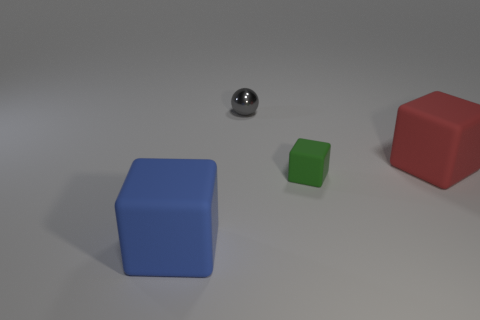What number of other things are there of the same size as the red block?
Provide a short and direct response. 1. How many large rubber cubes are on the left side of the blue cube?
Your response must be concise. 0. The blue rubber thing has what size?
Your response must be concise. Large. Does the cube that is left of the green rubber object have the same material as the tiny thing behind the red rubber block?
Your answer should be very brief. No. Are there any spheres that have the same color as the small block?
Your response must be concise. No. The other object that is the same size as the green object is what color?
Your response must be concise. Gray. There is a big rubber block that is behind the large blue matte object; does it have the same color as the small sphere?
Your answer should be very brief. No. Are there any small yellow balls made of the same material as the blue cube?
Give a very brief answer. No. Is the number of big matte things that are behind the large blue object less than the number of big blue rubber objects?
Give a very brief answer. No. Does the object that is on the right side of the green matte cube have the same size as the small gray thing?
Offer a very short reply. No. 